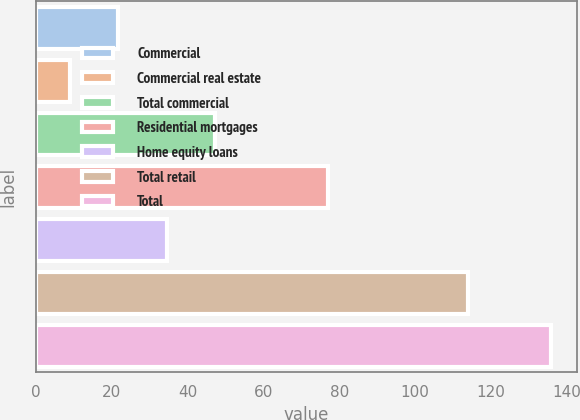Convert chart. <chart><loc_0><loc_0><loc_500><loc_500><bar_chart><fcel>Commercial<fcel>Commercial real estate<fcel>Total commercial<fcel>Residential mortgages<fcel>Home equity loans<fcel>Total retail<fcel>Total<nl><fcel>21.7<fcel>9<fcel>47.1<fcel>77<fcel>34.4<fcel>114<fcel>136<nl></chart> 